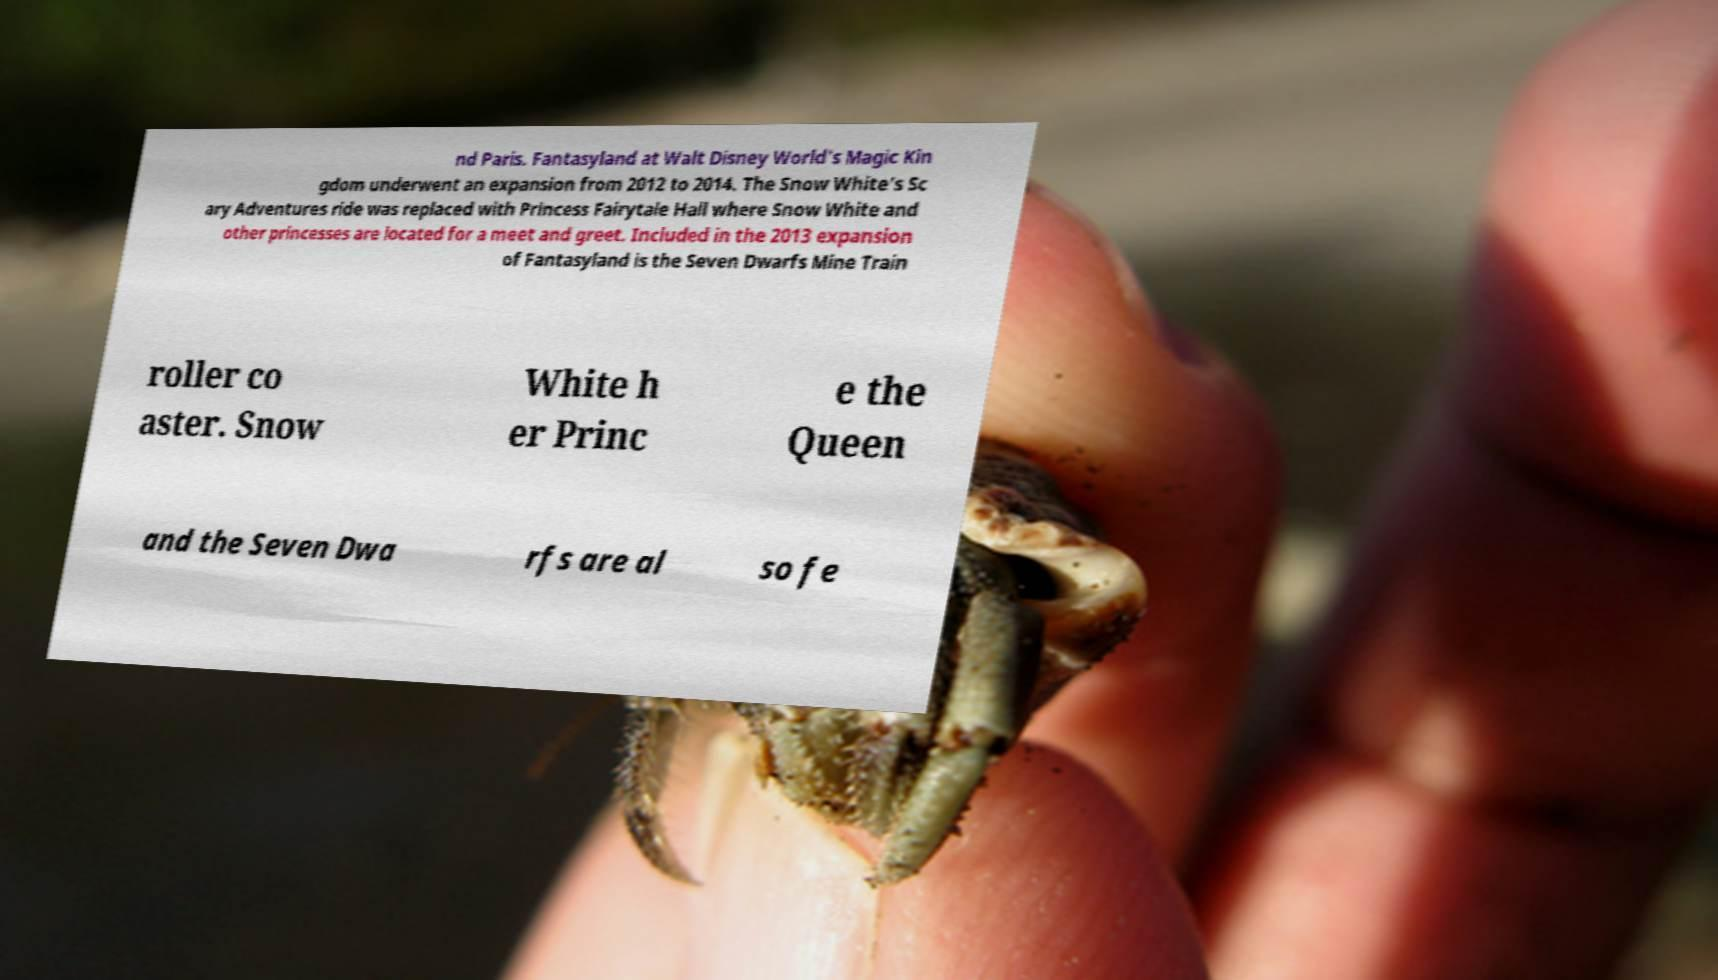Could you assist in decoding the text presented in this image and type it out clearly? nd Paris. Fantasyland at Walt Disney World's Magic Kin gdom underwent an expansion from 2012 to 2014. The Snow White's Sc ary Adventures ride was replaced with Princess Fairytale Hall where Snow White and other princesses are located for a meet and greet. Included in the 2013 expansion of Fantasyland is the Seven Dwarfs Mine Train roller co aster. Snow White h er Princ e the Queen and the Seven Dwa rfs are al so fe 